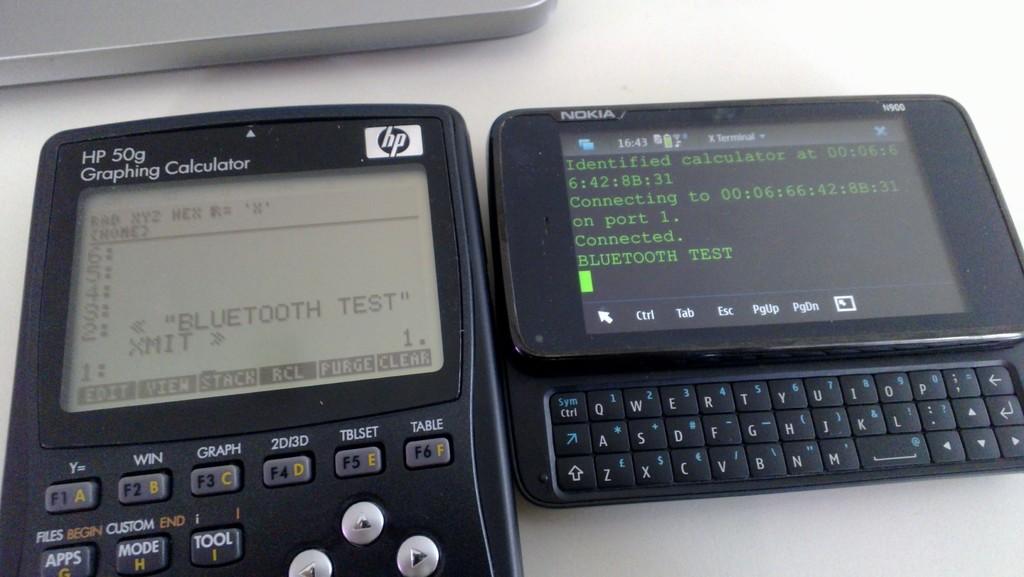What brand of graphing calculator is this?
Keep it short and to the point. Hp. What kind of test does it say on the screen of the left calculator?
Give a very brief answer. Bluetooth. 